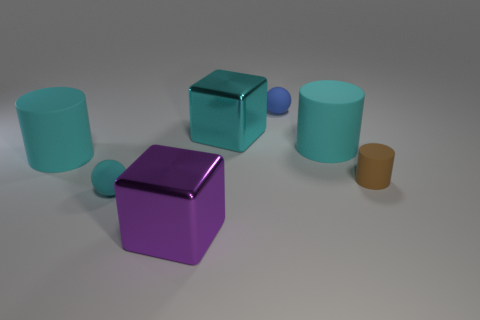What size is the cyan matte thing that is both to the left of the blue sphere and behind the cyan ball?
Provide a short and direct response. Large. What number of large objects are there?
Ensure brevity in your answer.  4. How many spheres are either things or tiny brown things?
Offer a terse response. 2. There is a metal object that is to the left of the block that is to the right of the big purple metallic block; what number of tiny cyan rubber spheres are behind it?
Offer a very short reply. 1. What is the color of the other shiny block that is the same size as the purple metallic cube?
Give a very brief answer. Cyan. What number of other things are the same color as the small rubber cylinder?
Provide a succinct answer. 0. Is the number of cyan objects that are to the left of the blue rubber sphere greater than the number of small cyan things?
Your answer should be compact. Yes. Do the blue sphere and the large purple thing have the same material?
Your answer should be very brief. No. How many things are either big metallic cubes that are in front of the tiny matte cylinder or small red balls?
Give a very brief answer. 1. How many other objects are the same size as the cyan ball?
Keep it short and to the point. 2. 